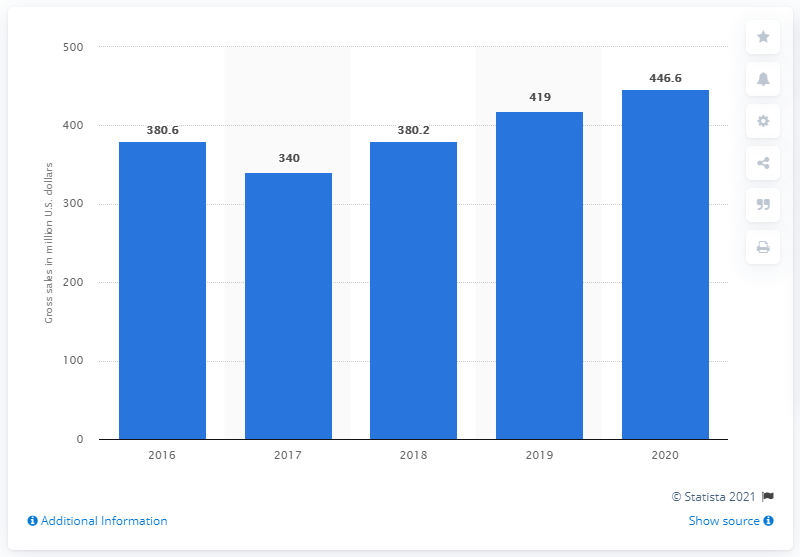Highlight a few significant elements in this photo. In 2020, the Hot Wheels brand of Mattel generated a total sales revenue of 446.6 million dollars in North America. In 2016, the Hot Wheels brand of Mattel generated approximately $419 million in gross sales in North America. 